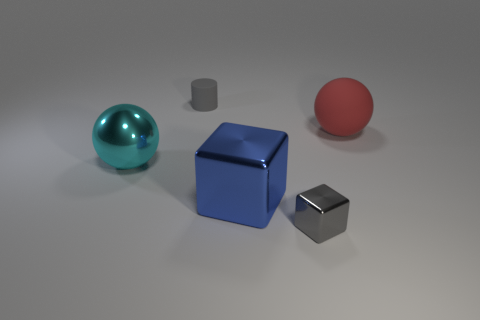Are there any cyan shiny things that are in front of the cyan metal ball in front of the cylinder?
Your response must be concise. No. What number of objects are large things that are on the left side of the small gray metal block or objects that are right of the cylinder?
Offer a terse response. 4. Are there any other things that have the same color as the big shiny ball?
Keep it short and to the point. No. What is the color of the ball that is to the left of the rubber thing that is on the right side of the gray object that is in front of the big rubber ball?
Give a very brief answer. Cyan. There is a ball to the left of the gray thing behind the red sphere; what is its size?
Provide a succinct answer. Large. What material is the thing that is right of the big metallic cube and to the left of the large red ball?
Your response must be concise. Metal. There is a blue block; is its size the same as the gray thing that is in front of the cyan metal ball?
Ensure brevity in your answer.  No. Are there any small green metal cylinders?
Offer a terse response. No. There is a cyan object that is the same shape as the red object; what is its material?
Ensure brevity in your answer.  Metal. There is a rubber thing left of the ball to the right of the gray matte cylinder left of the big red rubber ball; what size is it?
Offer a very short reply. Small. 